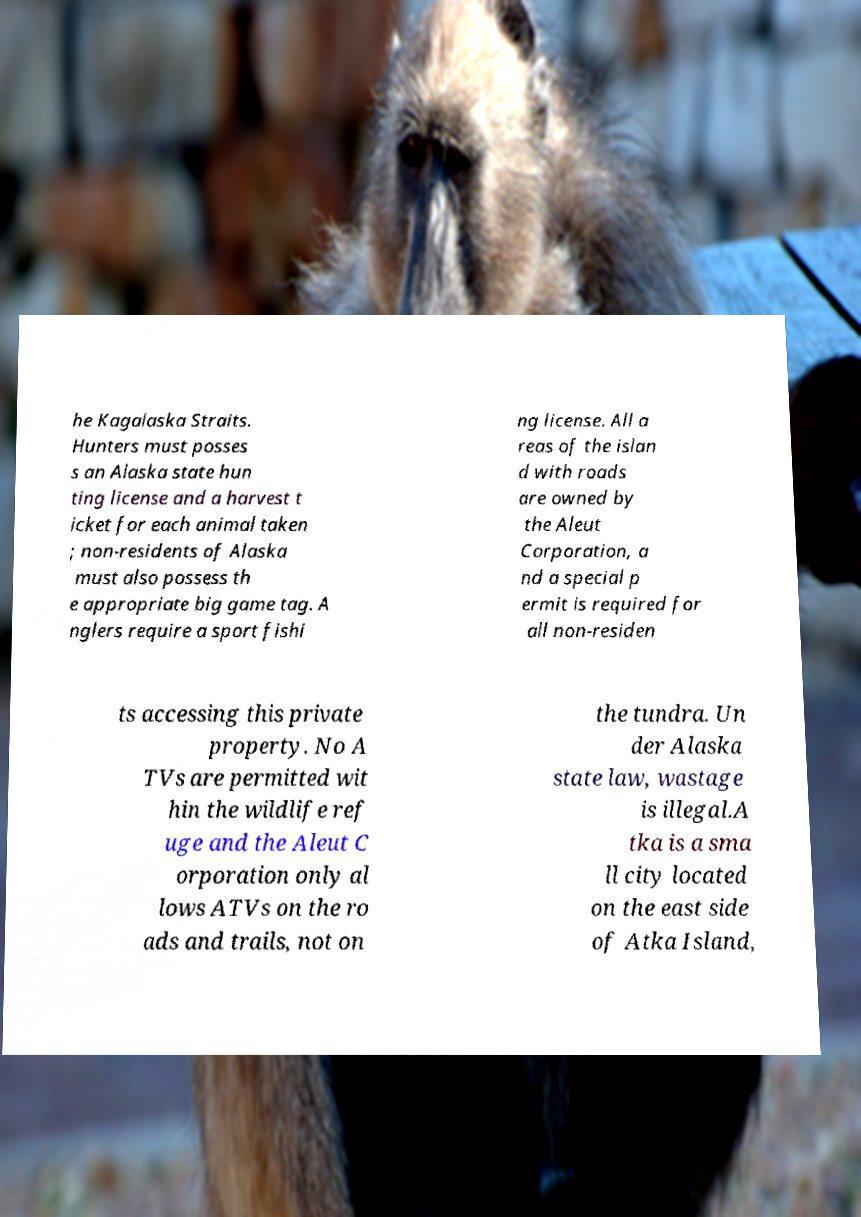Please read and relay the text visible in this image. What does it say? he Kagalaska Straits. Hunters must posses s an Alaska state hun ting license and a harvest t icket for each animal taken ; non-residents of Alaska must also possess th e appropriate big game tag. A nglers require a sport fishi ng license. All a reas of the islan d with roads are owned by the Aleut Corporation, a nd a special p ermit is required for all non-residen ts accessing this private property. No A TVs are permitted wit hin the wildlife ref uge and the Aleut C orporation only al lows ATVs on the ro ads and trails, not on the tundra. Un der Alaska state law, wastage is illegal.A tka is a sma ll city located on the east side of Atka Island, 